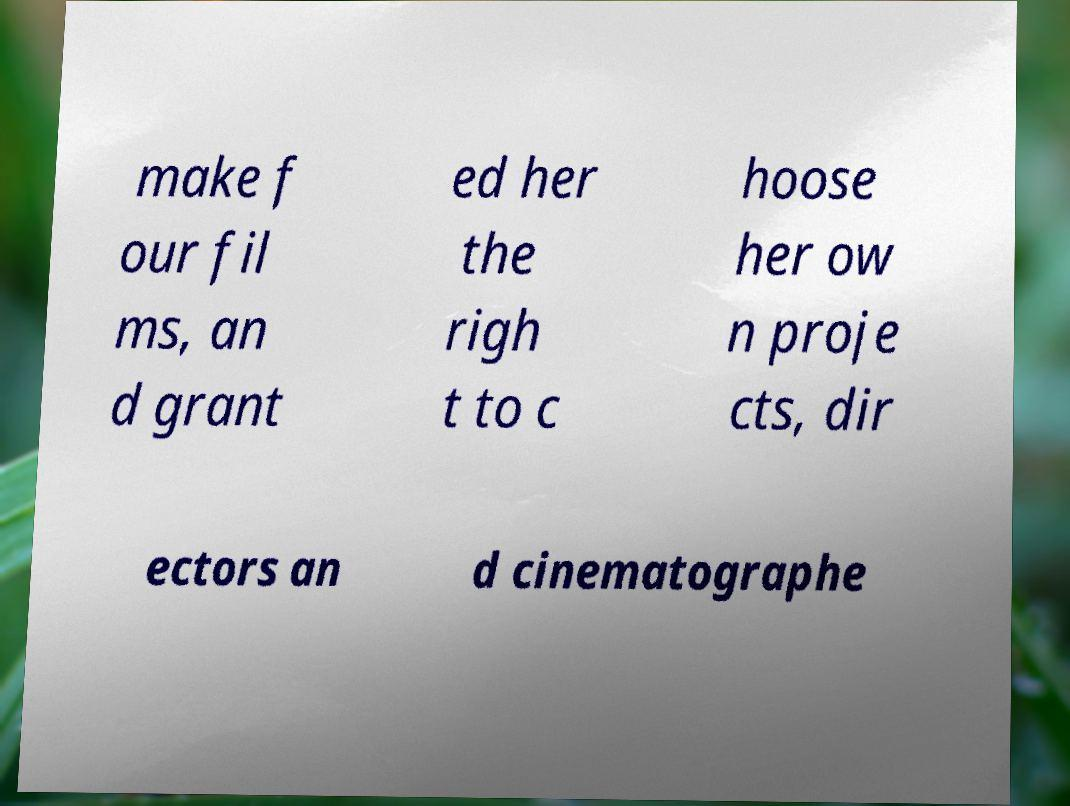Please read and relay the text visible in this image. What does it say? make f our fil ms, an d grant ed her the righ t to c hoose her ow n proje cts, dir ectors an d cinematographe 